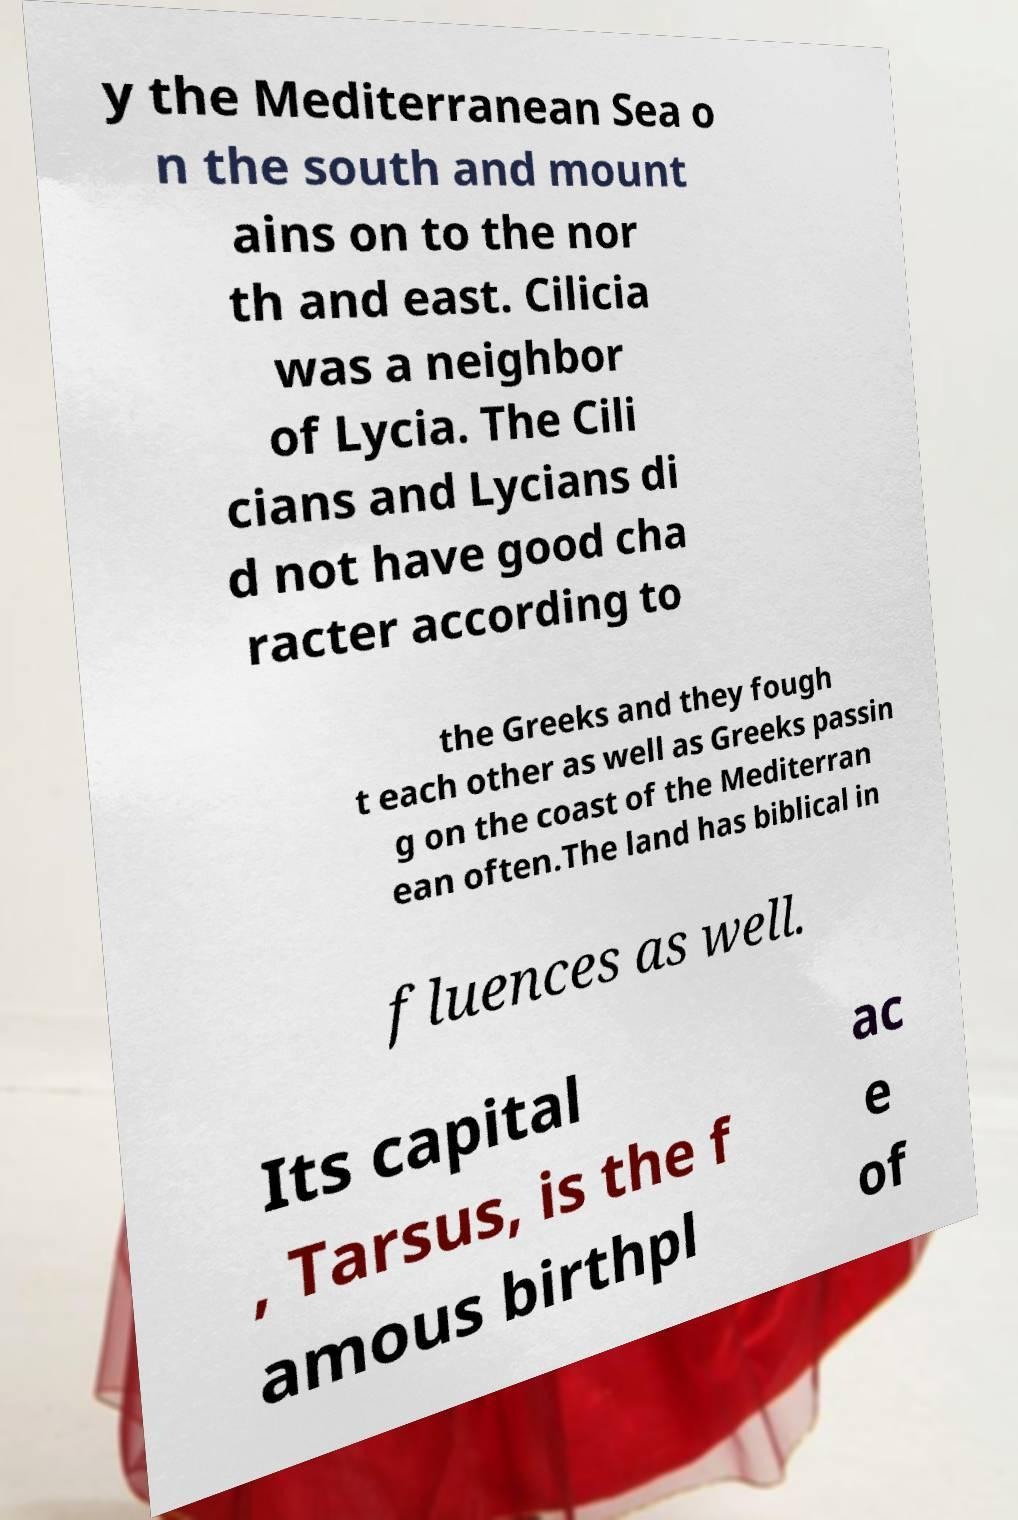For documentation purposes, I need the text within this image transcribed. Could you provide that? y the Mediterranean Sea o n the south and mount ains on to the nor th and east. Cilicia was a neighbor of Lycia. The Cili cians and Lycians di d not have good cha racter according to the Greeks and they fough t each other as well as Greeks passin g on the coast of the Mediterran ean often.The land has biblical in fluences as well. Its capital , Tarsus, is the f amous birthpl ac e of 